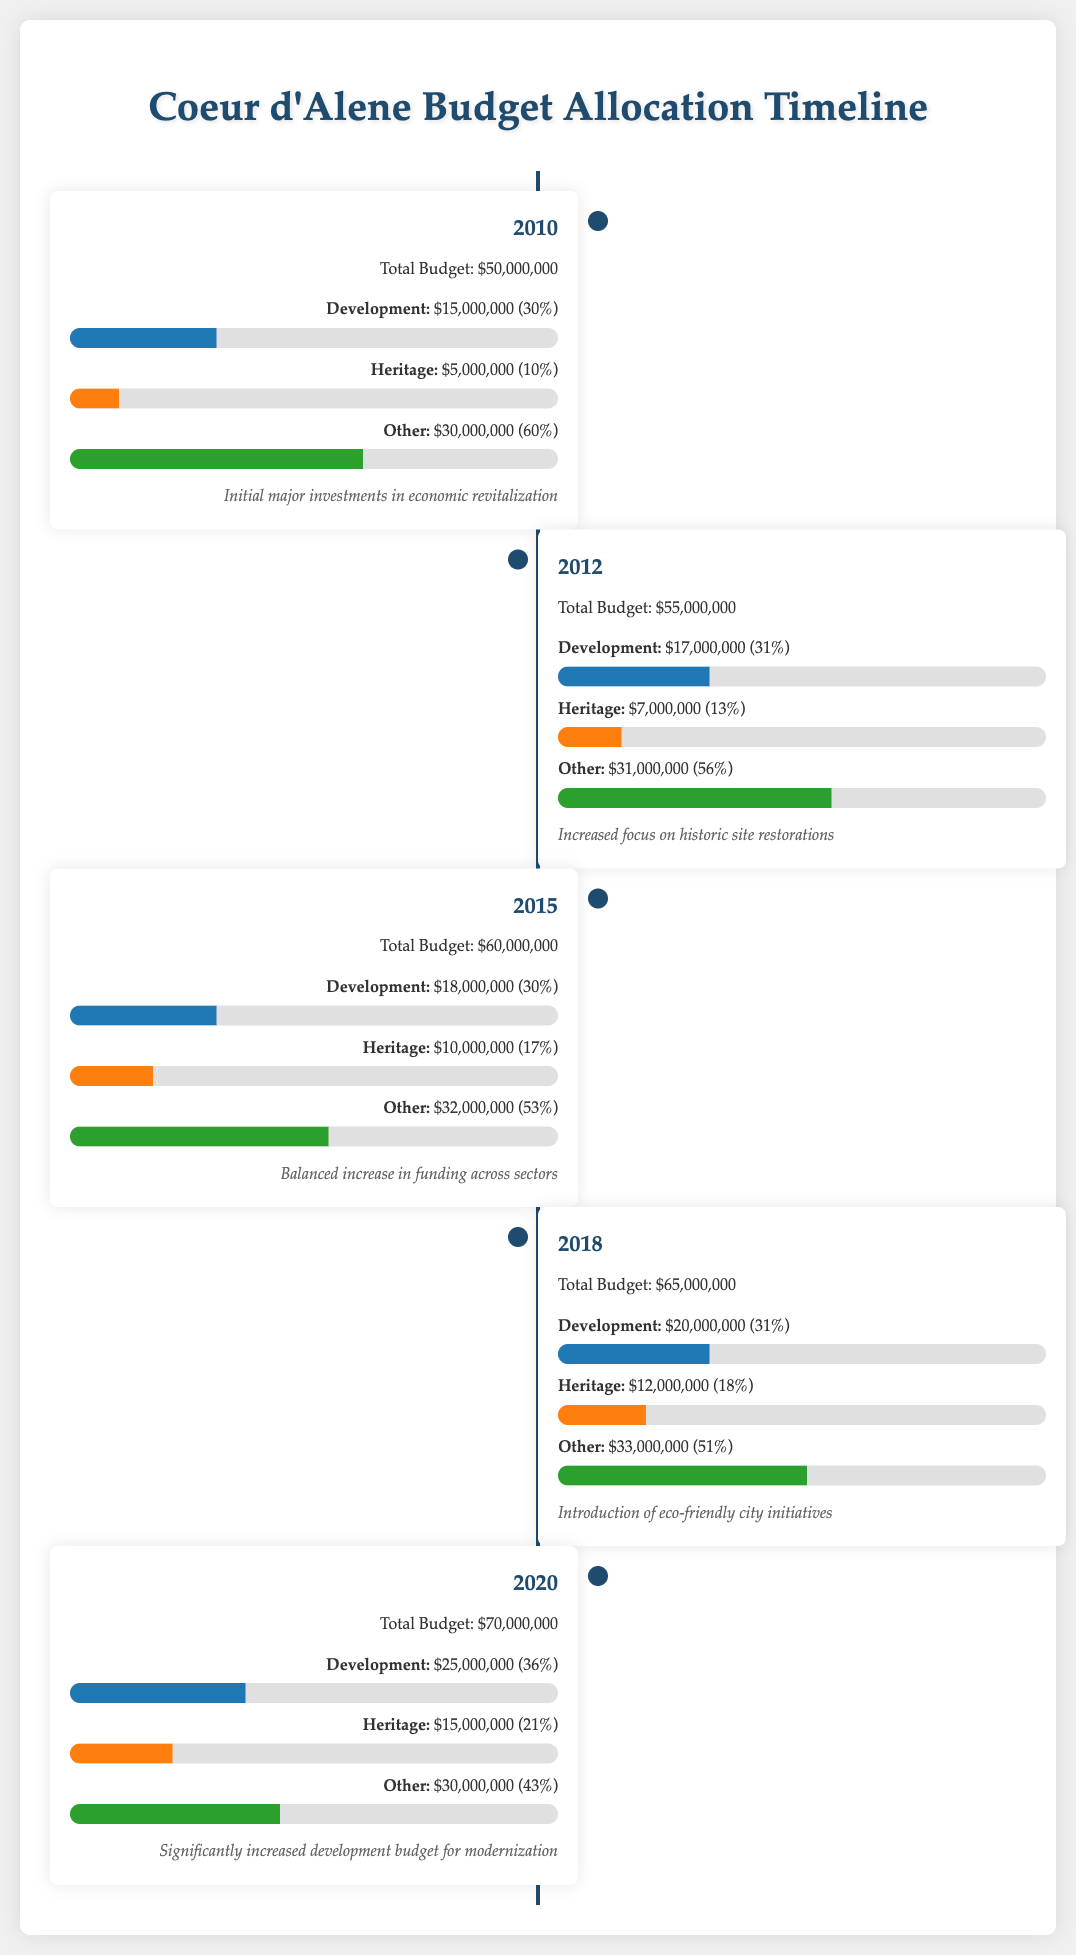What was the total budget in 2010? The total budget in 2010 is explicitly stated in the document as $50,000,000.
Answer: $50,000,000 Which year saw the highest allocation for heritage preservation? By comparing the heritage allocations across the timeline, the year 2020 shows the highest allocation of $15,000,000.
Answer: $15,000,000 What percentage of the budget was allocated to development in 2015? The document shows that in 2015, the development budget was $18,000,000, which is 30% of the total budget.
Answer: 30% How much did the development budget increase from 2010 to 2020? The development budget in 2010 was $15,000,000 and in 2020 it was $25,000,000, indicating an increase of $10,000,000.
Answer: $10,000,000 What color represents the heritage category in the infographic? The document indicates that the heritage category is represented by the color orange (#ff7f0e).
Answer: Orange How many different budget categories are mentioned in the timeline? The timeline describes three budget categories: Development, Heritage, and Other.
Answer: Three What note is associated with the year 2018? The year 2018 is associated with the note regarding the introduction of eco-friendly city initiatives.
Answer: Introduction of eco-friendly city initiatives Which year experienced a balanced increase in funding across sectors? The year 2015 is noted for having a balanced increase in funding across its budget categories.
Answer: 2015 